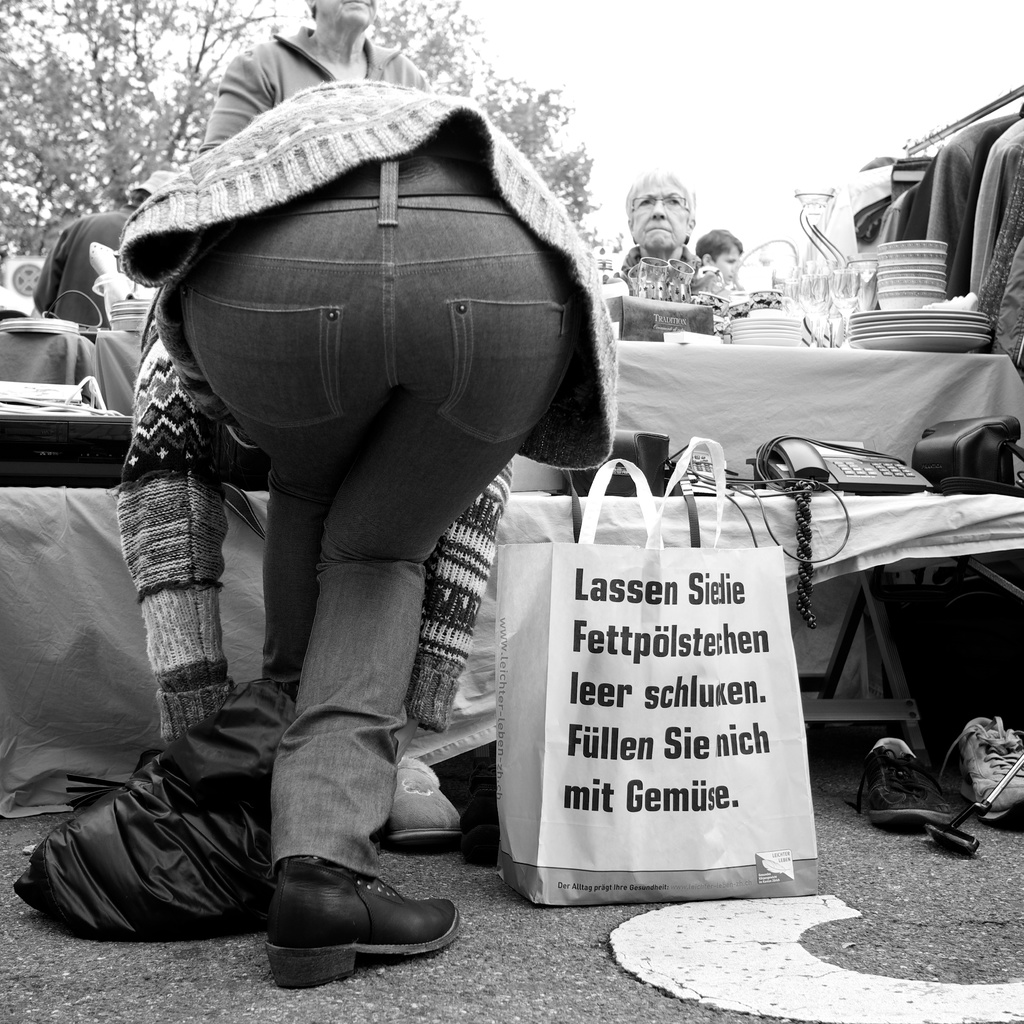What might be the significance of the phrase on the bag in the context of a flea market? The phrase on the bag translates as a quirky statement about leaving 'fat pots empty' and not filling them with vegetables, possibly representing a humorous or ironic commentary on consumer habits or preferences found at flea markets. It might suggest a playful critique or a personal joke related to the types of goods one tends to buy at such markets. 